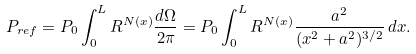<formula> <loc_0><loc_0><loc_500><loc_500>P _ { r e f } = P _ { 0 } \int _ { 0 } ^ { L } R ^ { N ( x ) } \frac { d \Omega } { 2 \pi } = P _ { 0 } \int _ { 0 } ^ { L } R ^ { N ( x ) } \frac { a ^ { 2 } } { ( x ^ { 2 } + a ^ { 2 } ) ^ { 3 / 2 } } \, d x .</formula> 